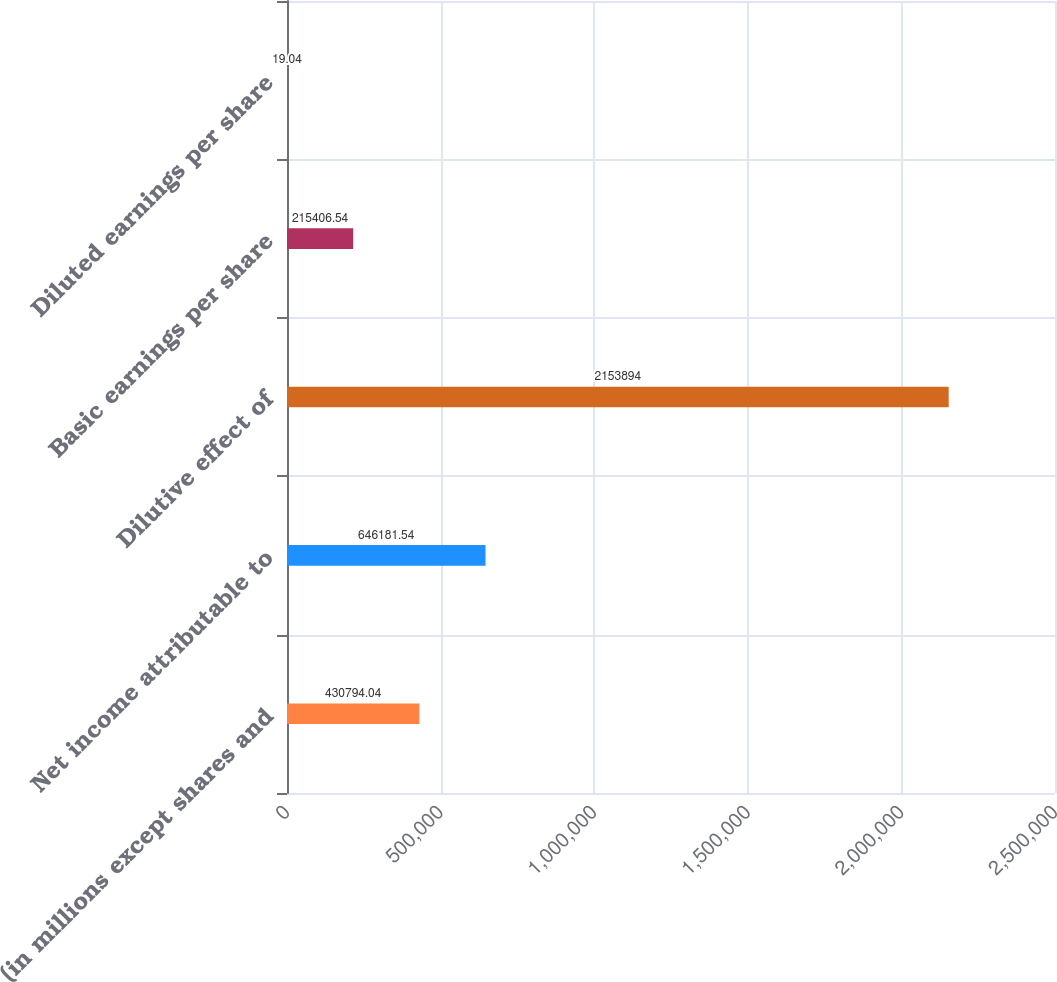Convert chart. <chart><loc_0><loc_0><loc_500><loc_500><bar_chart><fcel>(in millions except shares and<fcel>Net income attributable to<fcel>Dilutive effect of<fcel>Basic earnings per share<fcel>Diluted earnings per share<nl><fcel>430794<fcel>646182<fcel>2.15389e+06<fcel>215407<fcel>19.04<nl></chart> 